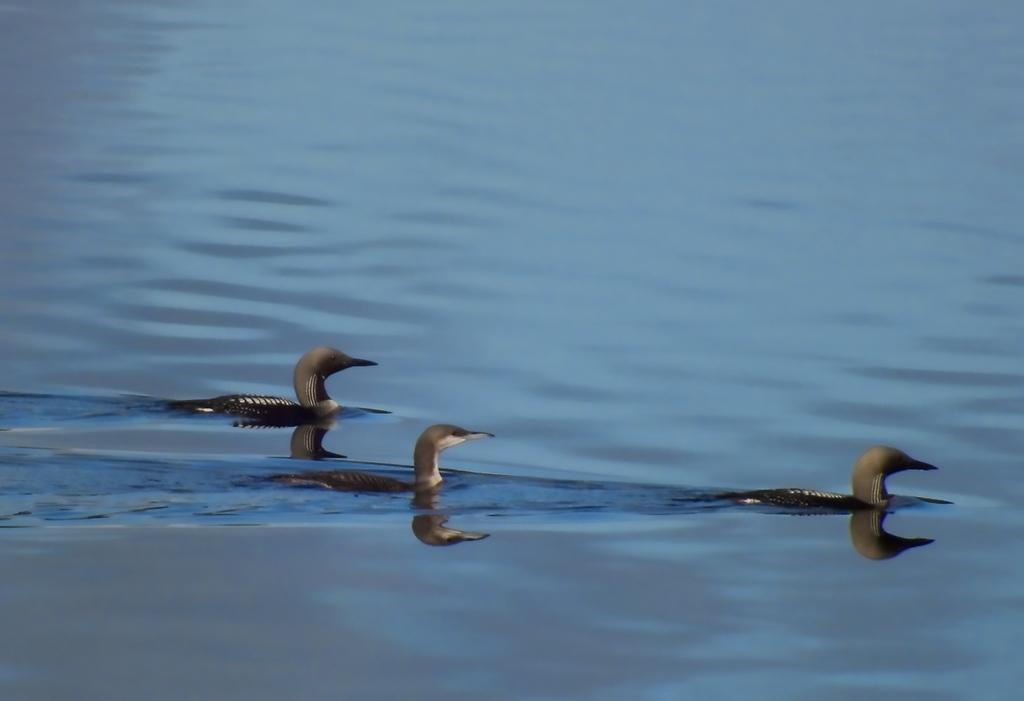How many birds are present in the image? There are three birds in the image. Where are the birds located in the image? The birds are on the surface of the water. What type of books can be seen floating behind the birds in the image? There are no books present in the image; it features three birds on the surface of the water. 